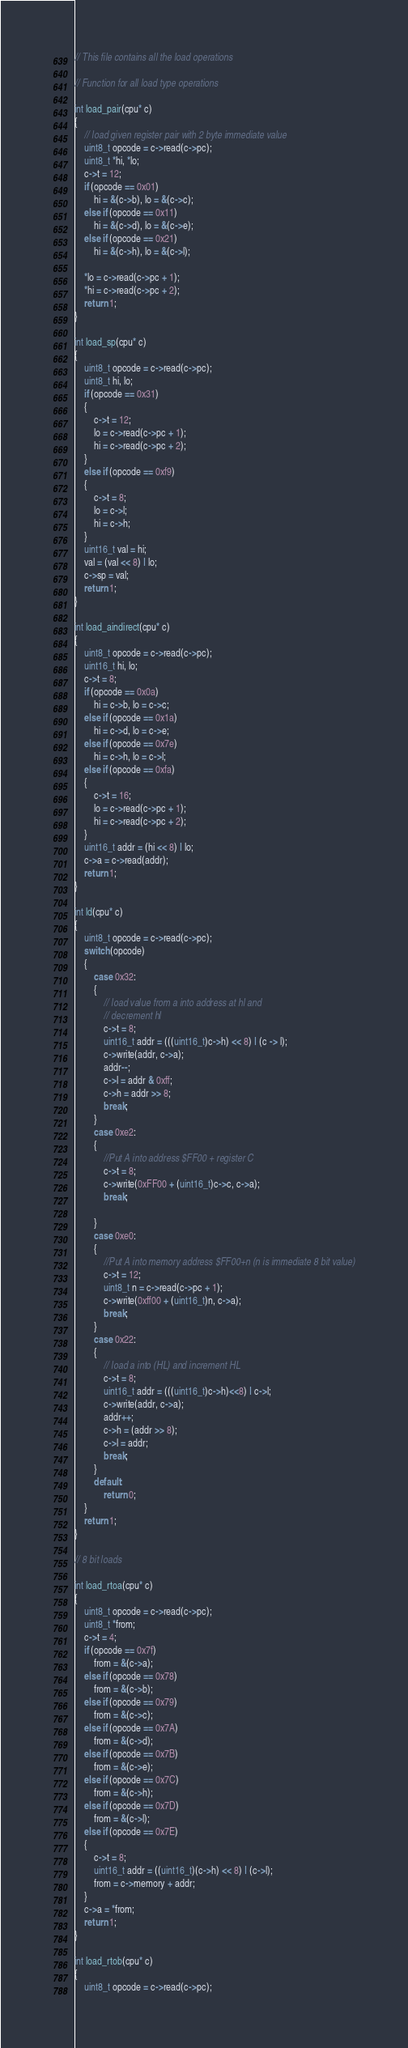<code> <loc_0><loc_0><loc_500><loc_500><_C++_>// This file contains all the load operations

// Function for all load type operations

int load_pair(cpu* c)
{
    // load given register pair with 2 byte immediate value
    uint8_t opcode = c->read(c->pc);
    uint8_t *hi, *lo;
    c->t = 12;
    if (opcode == 0x01)
        hi = &(c->b), lo = &(c->c);
    else if (opcode == 0x11)
        hi = &(c->d), lo = &(c->e);
    else if (opcode == 0x21)
        hi = &(c->h), lo = &(c->l);

    *lo = c->read(c->pc + 1);
    *hi = c->read(c->pc + 2);
    return 1;
}

int load_sp(cpu* c)
{
    uint8_t opcode = c->read(c->pc);
    uint8_t hi, lo;
    if (opcode == 0x31)
    {
        c->t = 12;
        lo = c->read(c->pc + 1);
        hi = c->read(c->pc + 2);
    }
    else if (opcode == 0xf9)
    {
        c->t = 8;
        lo = c->l;
        hi = c->h;
    }
    uint16_t val = hi;
    val = (val << 8) | lo;
    c->sp = val;
    return 1;
}

int load_aindirect(cpu* c)
{
    uint8_t opcode = c->read(c->pc);
    uint16_t hi, lo;
    c->t = 8;
    if (opcode == 0x0a)
        hi = c->b, lo = c->c;
    else if (opcode == 0x1a)
        hi = c->d, lo = c->e;
    else if (opcode == 0x7e)
        hi = c->h, lo = c->l;
    else if (opcode == 0xfa)
    {
        c->t = 16;
        lo = c->read(c->pc + 1);
        hi = c->read(c->pc + 2);
    }
    uint16_t addr = (hi << 8) | lo;
    c->a = c->read(addr);
    return 1;
}

int ld(cpu* c)
{
    uint8_t opcode = c->read(c->pc);
    switch (opcode)
    {
        case 0x32:
        {
            // load value from a into address at hl and
            // decrement hl
            c->t = 8;
            uint16_t addr = (((uint16_t)c->h) << 8) | (c -> l);
            c->write(addr, c->a);
            addr--;
            c->l = addr & 0xff;
            c->h = addr >> 8;
            break;
        }
        case 0xe2:
        {
            //Put A into address $FF00 + register C
            c->t = 8;
            c->write(0xFF00 + (uint16_t)c->c, c->a);
            break;

        }
        case 0xe0:
        {
            //Put A into memory address $FF00+n (n is immediate 8 bit value)
            c->t = 12;
            uint8_t n = c->read(c->pc + 1);
            c->write(0xff00 + (uint16_t)n, c->a);
            break;
        }
        case 0x22:
        {
            // load a into (HL) and increment HL
            c->t = 8;
            uint16_t addr = (((uint16_t)c->h)<<8) | c->l;
            c->write(addr, c->a);
            addr++;
            c->h = (addr >> 8);
            c->l = addr;
            break;
        }
        default:
            return 0;
    }
    return 1;
}

// 8 bit loads

int load_rtoa(cpu* c)
{
    uint8_t opcode = c->read(c->pc);
    uint8_t *from;
    c->t = 4;
    if (opcode == 0x7f)
        from = &(c->a);
    else if (opcode == 0x78)
        from = &(c->b);
    else if (opcode == 0x79)
        from = &(c->c);
    else if (opcode == 0x7A)
        from = &(c->d);
    else if (opcode == 0x7B)
        from = &(c->e);
    else if (opcode == 0x7C)
        from = &(c->h);
    else if (opcode == 0x7D)
        from = &(c->l);
    else if (opcode == 0x7E)
    {
        c->t = 8;
        uint16_t addr = ((uint16_t)(c->h) << 8) | (c->l);
        from = c->memory + addr;
    }
    c->a = *from;
    return 1;
}

int load_rtob(cpu* c)
{
    uint8_t opcode = c->read(c->pc);</code> 